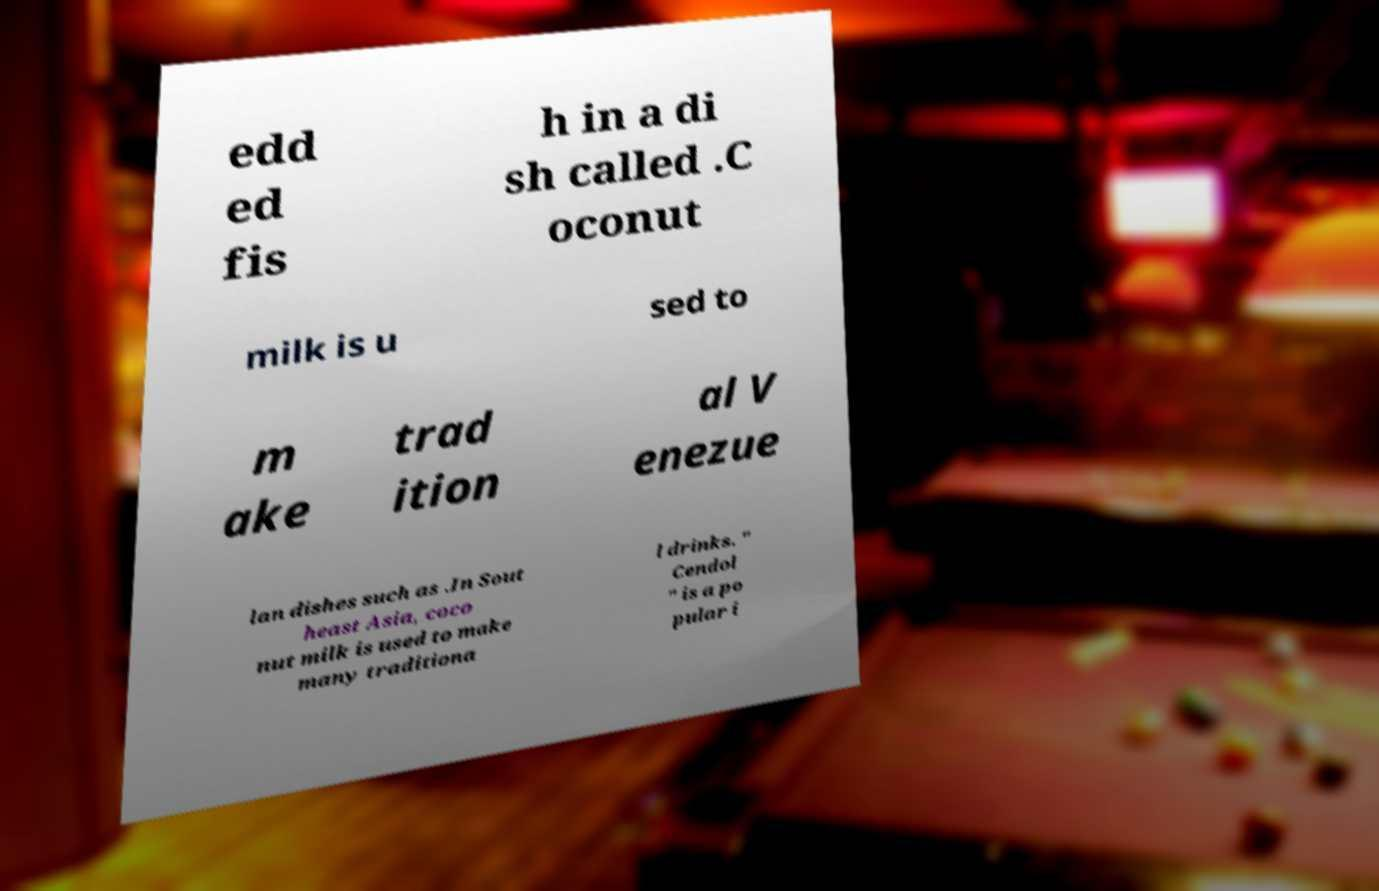For documentation purposes, I need the text within this image transcribed. Could you provide that? edd ed fis h in a di sh called .C oconut milk is u sed to m ake trad ition al V enezue lan dishes such as .In Sout heast Asia, coco nut milk is used to make many traditiona l drinks. " Cendol " is a po pular i 